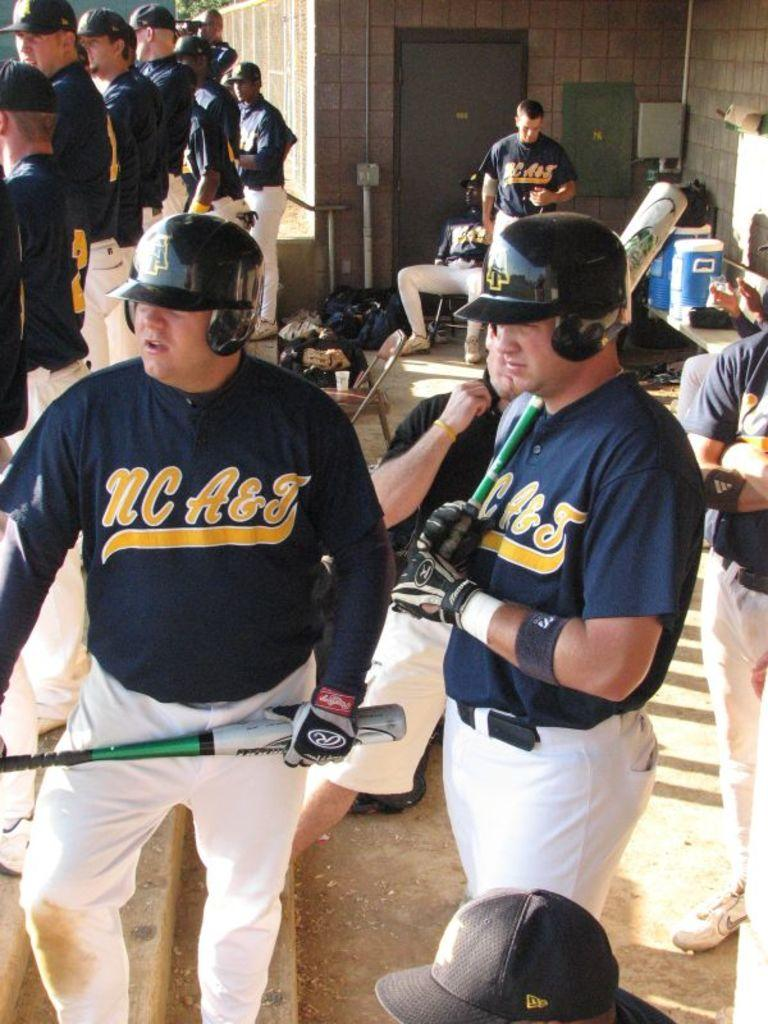<image>
Render a clear and concise summary of the photo. Baseball players looking on while wearing jerseys that say "NC A&J". 